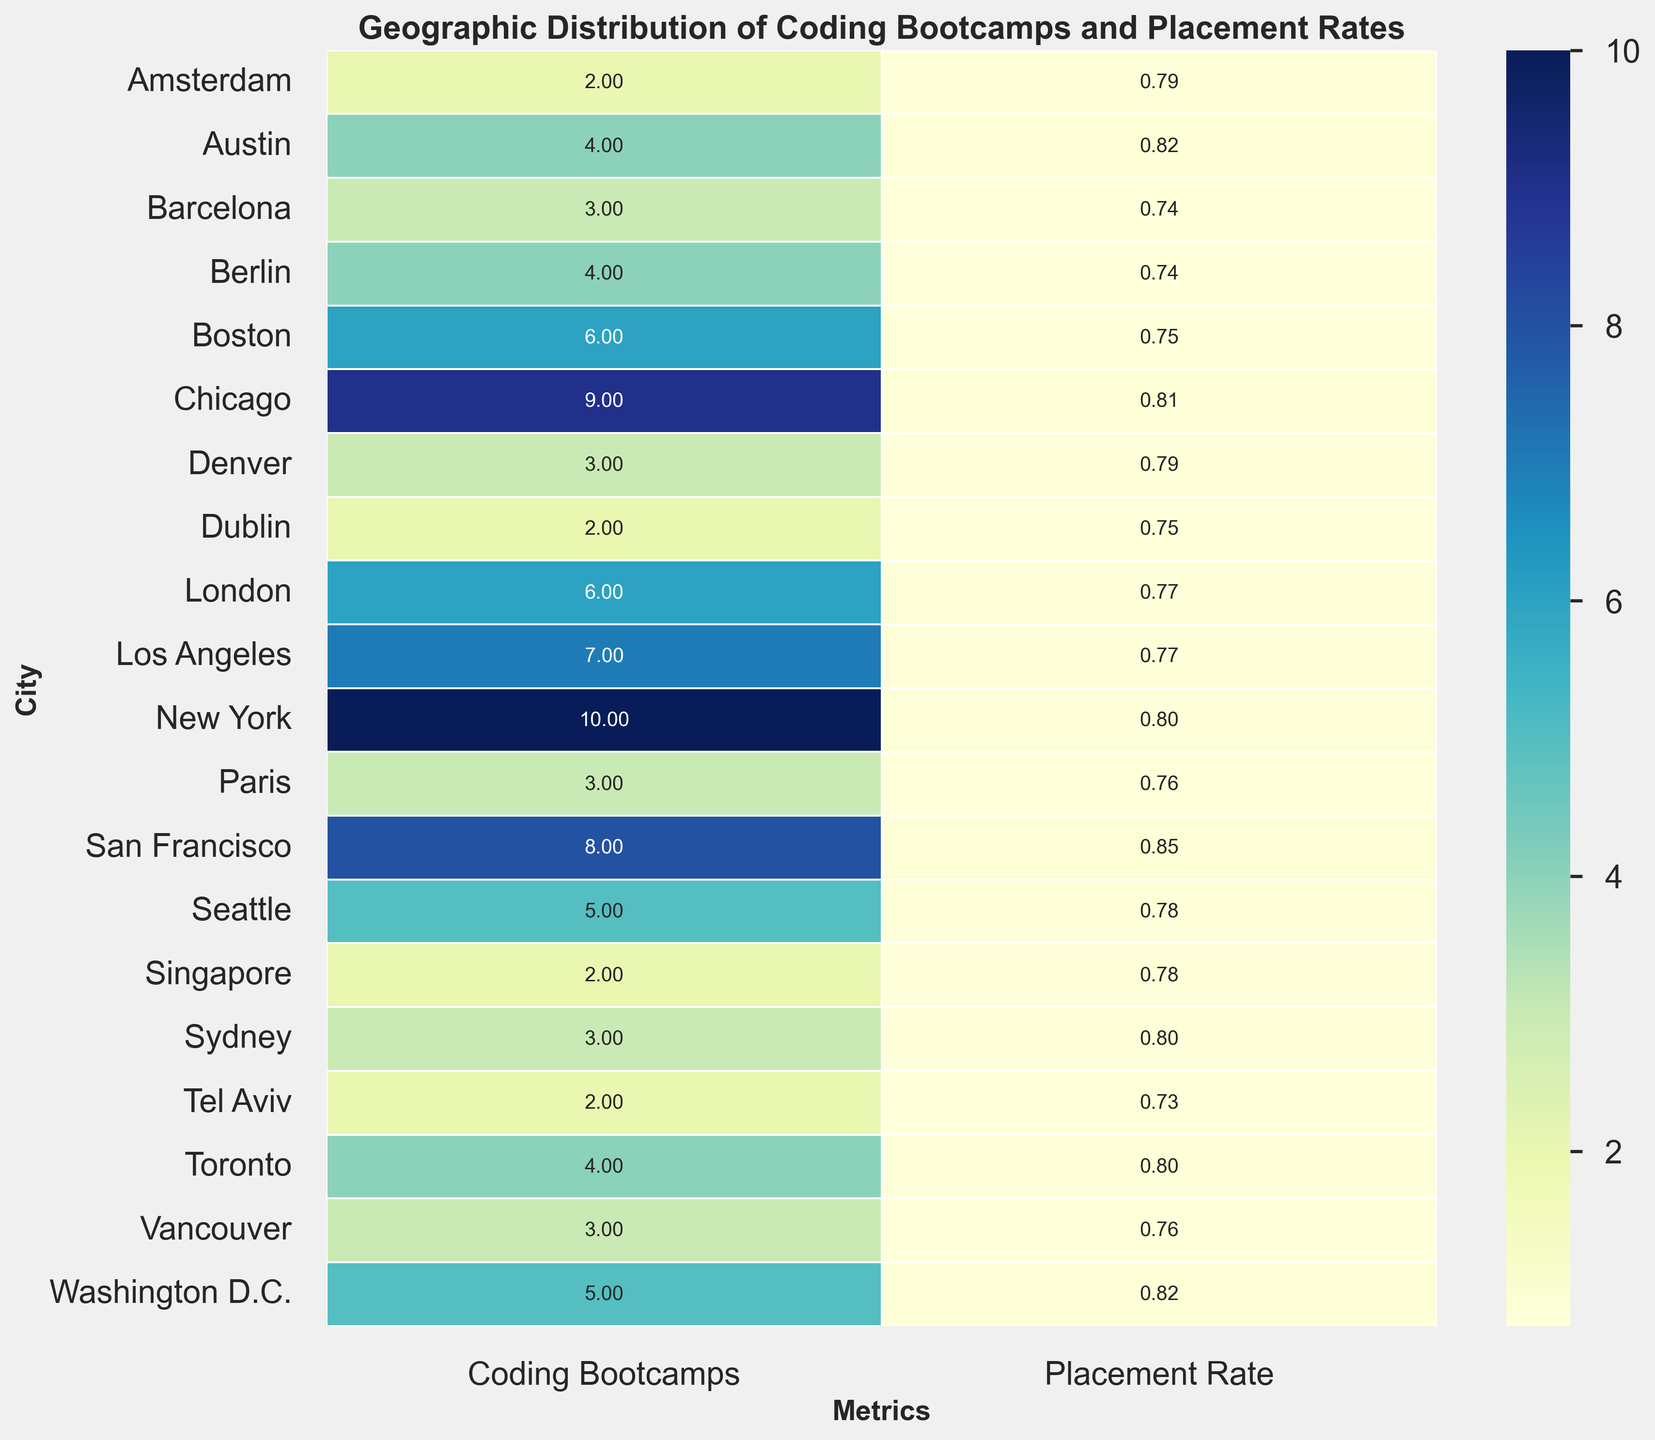What's the city with the highest number of coding bootcamps? The heatmap shows the number of coding bootcamps for each city. Look for the city with the highest numerical value in the "Coding Bootcamps" column.
Answer: New York Which city has the highest placement rate among cities with 5 coding bootcamps? Identify the cities with 5 coding bootcamps from the heatmap and compare their placement rates to find the highest one.
Answer: Washington D.C Between London and Sydney, which city has a higher placement rate? Check the placement rates for London and Sydney in the heatmap and compare to see which is higher.
Answer: Sydney What is the average placement rate of Berlin and Tel Aviv? Locate the placement rates of Berlin and Tel Aviv, sum them, and divide by 2: (74 + 73) / 2.
Answer: 73.5 Which city has the lowest number of coding bootcamps and what is its placement rate? Find the city with the smallest value in the "Coding Bootcamps" column and note its placement rate.
Answer: Tel Aviv, 73 Which two cities have the most similar placement rates? Compare the placement rates of all cities to find the pair with the closest values.
Answer: New York and Toronto What is the total number of coding bootcamps in San Francisco and Chicago? Add the number of coding bootcamps from San Francisco and Chicago: 8 + 9.
Answer: 17 What is the color shade for cities with placement rates above 80%? Observe the color shade in the heatmap for cities with placement rates greater than 80% and describe it.
Answer: Light Blue/Green How many cities have a placement rate of 80% or higher? Count all cities in the heatmap with a placement rate of 80% or above.
Answer: 8 Compare the number of coding bootcamps in New York and Los Angeles. Which city has more? Compare the "Coding Bootcamps" values for New York and Los Angeles to see which is higher.
Answer: New York 